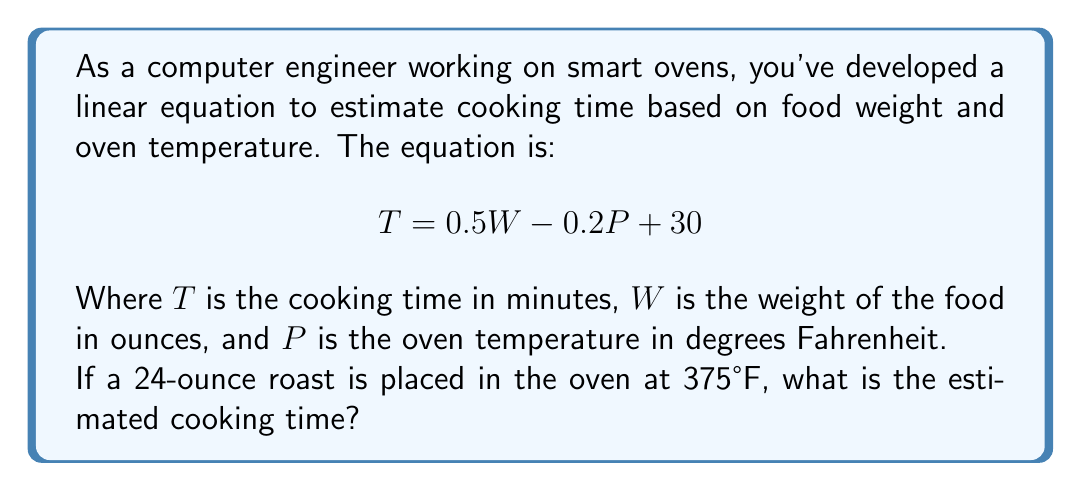Can you answer this question? To solve this problem, we need to use the given linear equation and substitute the known values:

$T = 0.5W - 0.2P + 30$

Where:
$W = 24$ ounces (weight of the roast)
$P = 375°F$ (oven temperature)

Let's substitute these values into the equation:

$T = 0.5(24) - 0.2(375) + 30$

Now, let's solve the equation step by step:

1. Calculate $0.5(24)$:
   $0.5(24) = 12$

2. Calculate $0.2(375)$:
   $0.2(375) = 75$

3. Substitute these values into the equation:
   $T = 12 - 75 + 30$

4. Perform the addition and subtraction:
   $T = -33 + 30 = -3$

The result is negative, which doesn't make sense for cooking time. In practical applications, we would set a minimum cooking time (e.g., 1 minute) for such cases. Therefore, the estimated cooking time would be 1 minute.
Answer: 1 minute 